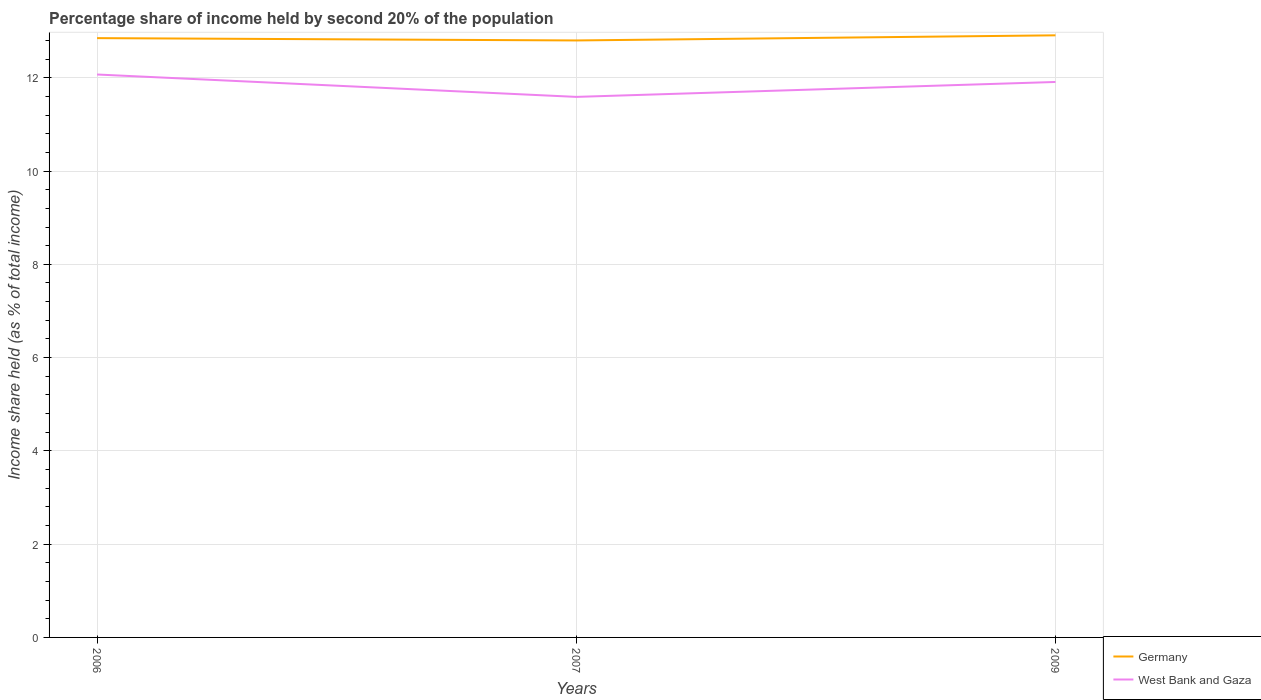How many different coloured lines are there?
Your answer should be compact. 2. Does the line corresponding to West Bank and Gaza intersect with the line corresponding to Germany?
Offer a very short reply. No. Is the number of lines equal to the number of legend labels?
Your answer should be compact. Yes. What is the total share of income held by second 20% of the population in West Bank and Gaza in the graph?
Provide a short and direct response. 0.16. What is the difference between the highest and the second highest share of income held by second 20% of the population in Germany?
Make the answer very short. 0.11. Is the share of income held by second 20% of the population in Germany strictly greater than the share of income held by second 20% of the population in West Bank and Gaza over the years?
Offer a very short reply. No. How many lines are there?
Offer a terse response. 2. How many years are there in the graph?
Offer a very short reply. 3. Does the graph contain grids?
Provide a succinct answer. Yes. Where does the legend appear in the graph?
Offer a terse response. Bottom right. How many legend labels are there?
Provide a short and direct response. 2. What is the title of the graph?
Provide a succinct answer. Percentage share of income held by second 20% of the population. Does "Italy" appear as one of the legend labels in the graph?
Your response must be concise. No. What is the label or title of the Y-axis?
Provide a succinct answer. Income share held (as % of total income). What is the Income share held (as % of total income) in Germany in 2006?
Your answer should be compact. 12.85. What is the Income share held (as % of total income) in West Bank and Gaza in 2006?
Your answer should be very brief. 12.07. What is the Income share held (as % of total income) in West Bank and Gaza in 2007?
Make the answer very short. 11.59. What is the Income share held (as % of total income) of Germany in 2009?
Provide a succinct answer. 12.91. What is the Income share held (as % of total income) of West Bank and Gaza in 2009?
Offer a terse response. 11.91. Across all years, what is the maximum Income share held (as % of total income) in Germany?
Your answer should be very brief. 12.91. Across all years, what is the maximum Income share held (as % of total income) in West Bank and Gaza?
Offer a very short reply. 12.07. Across all years, what is the minimum Income share held (as % of total income) of Germany?
Your answer should be very brief. 12.8. Across all years, what is the minimum Income share held (as % of total income) of West Bank and Gaza?
Make the answer very short. 11.59. What is the total Income share held (as % of total income) of Germany in the graph?
Your response must be concise. 38.56. What is the total Income share held (as % of total income) in West Bank and Gaza in the graph?
Make the answer very short. 35.57. What is the difference between the Income share held (as % of total income) in West Bank and Gaza in 2006 and that in 2007?
Provide a short and direct response. 0.48. What is the difference between the Income share held (as % of total income) of Germany in 2006 and that in 2009?
Make the answer very short. -0.06. What is the difference between the Income share held (as % of total income) in West Bank and Gaza in 2006 and that in 2009?
Provide a short and direct response. 0.16. What is the difference between the Income share held (as % of total income) in Germany in 2007 and that in 2009?
Offer a very short reply. -0.11. What is the difference between the Income share held (as % of total income) in West Bank and Gaza in 2007 and that in 2009?
Ensure brevity in your answer.  -0.32. What is the difference between the Income share held (as % of total income) in Germany in 2006 and the Income share held (as % of total income) in West Bank and Gaza in 2007?
Make the answer very short. 1.26. What is the difference between the Income share held (as % of total income) of Germany in 2006 and the Income share held (as % of total income) of West Bank and Gaza in 2009?
Ensure brevity in your answer.  0.94. What is the difference between the Income share held (as % of total income) of Germany in 2007 and the Income share held (as % of total income) of West Bank and Gaza in 2009?
Ensure brevity in your answer.  0.89. What is the average Income share held (as % of total income) in Germany per year?
Give a very brief answer. 12.85. What is the average Income share held (as % of total income) of West Bank and Gaza per year?
Offer a very short reply. 11.86. In the year 2006, what is the difference between the Income share held (as % of total income) of Germany and Income share held (as % of total income) of West Bank and Gaza?
Your answer should be compact. 0.78. In the year 2007, what is the difference between the Income share held (as % of total income) in Germany and Income share held (as % of total income) in West Bank and Gaza?
Your answer should be compact. 1.21. In the year 2009, what is the difference between the Income share held (as % of total income) of Germany and Income share held (as % of total income) of West Bank and Gaza?
Provide a succinct answer. 1. What is the ratio of the Income share held (as % of total income) in West Bank and Gaza in 2006 to that in 2007?
Provide a short and direct response. 1.04. What is the ratio of the Income share held (as % of total income) in Germany in 2006 to that in 2009?
Offer a terse response. 1. What is the ratio of the Income share held (as % of total income) in West Bank and Gaza in 2006 to that in 2009?
Make the answer very short. 1.01. What is the ratio of the Income share held (as % of total income) of Germany in 2007 to that in 2009?
Offer a very short reply. 0.99. What is the ratio of the Income share held (as % of total income) in West Bank and Gaza in 2007 to that in 2009?
Offer a very short reply. 0.97. What is the difference between the highest and the second highest Income share held (as % of total income) of Germany?
Your response must be concise. 0.06. What is the difference between the highest and the second highest Income share held (as % of total income) of West Bank and Gaza?
Make the answer very short. 0.16. What is the difference between the highest and the lowest Income share held (as % of total income) in Germany?
Your answer should be compact. 0.11. What is the difference between the highest and the lowest Income share held (as % of total income) of West Bank and Gaza?
Offer a terse response. 0.48. 